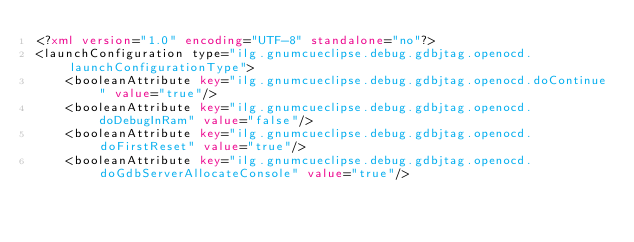Convert code to text. <code><loc_0><loc_0><loc_500><loc_500><_XML_><?xml version="1.0" encoding="UTF-8" standalone="no"?>
<launchConfiguration type="ilg.gnumcueclipse.debug.gdbjtag.openocd.launchConfigurationType">
    <booleanAttribute key="ilg.gnumcueclipse.debug.gdbjtag.openocd.doContinue" value="true"/>
    <booleanAttribute key="ilg.gnumcueclipse.debug.gdbjtag.openocd.doDebugInRam" value="false"/>
    <booleanAttribute key="ilg.gnumcueclipse.debug.gdbjtag.openocd.doFirstReset" value="true"/>
    <booleanAttribute key="ilg.gnumcueclipse.debug.gdbjtag.openocd.doGdbServerAllocateConsole" value="true"/></code> 